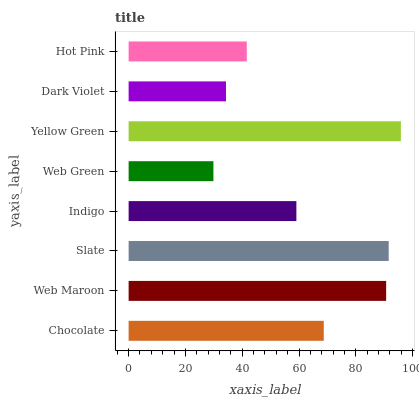Is Web Green the minimum?
Answer yes or no. Yes. Is Yellow Green the maximum?
Answer yes or no. Yes. Is Web Maroon the minimum?
Answer yes or no. No. Is Web Maroon the maximum?
Answer yes or no. No. Is Web Maroon greater than Chocolate?
Answer yes or no. Yes. Is Chocolate less than Web Maroon?
Answer yes or no. Yes. Is Chocolate greater than Web Maroon?
Answer yes or no. No. Is Web Maroon less than Chocolate?
Answer yes or no. No. Is Chocolate the high median?
Answer yes or no. Yes. Is Indigo the low median?
Answer yes or no. Yes. Is Web Green the high median?
Answer yes or no. No. Is Hot Pink the low median?
Answer yes or no. No. 